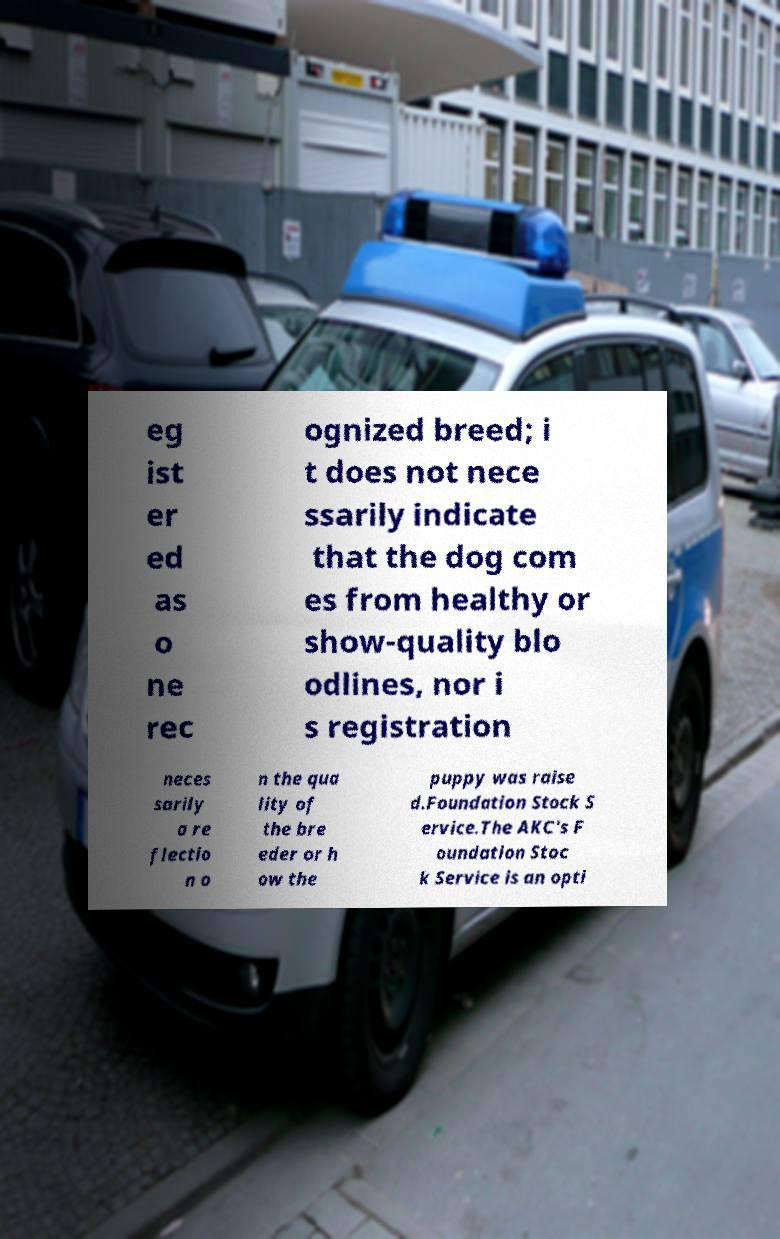Please read and relay the text visible in this image. What does it say? eg ist er ed as o ne rec ognized breed; i t does not nece ssarily indicate that the dog com es from healthy or show-quality blo odlines, nor i s registration neces sarily a re flectio n o n the qua lity of the bre eder or h ow the puppy was raise d.Foundation Stock S ervice.The AKC's F oundation Stoc k Service is an opti 